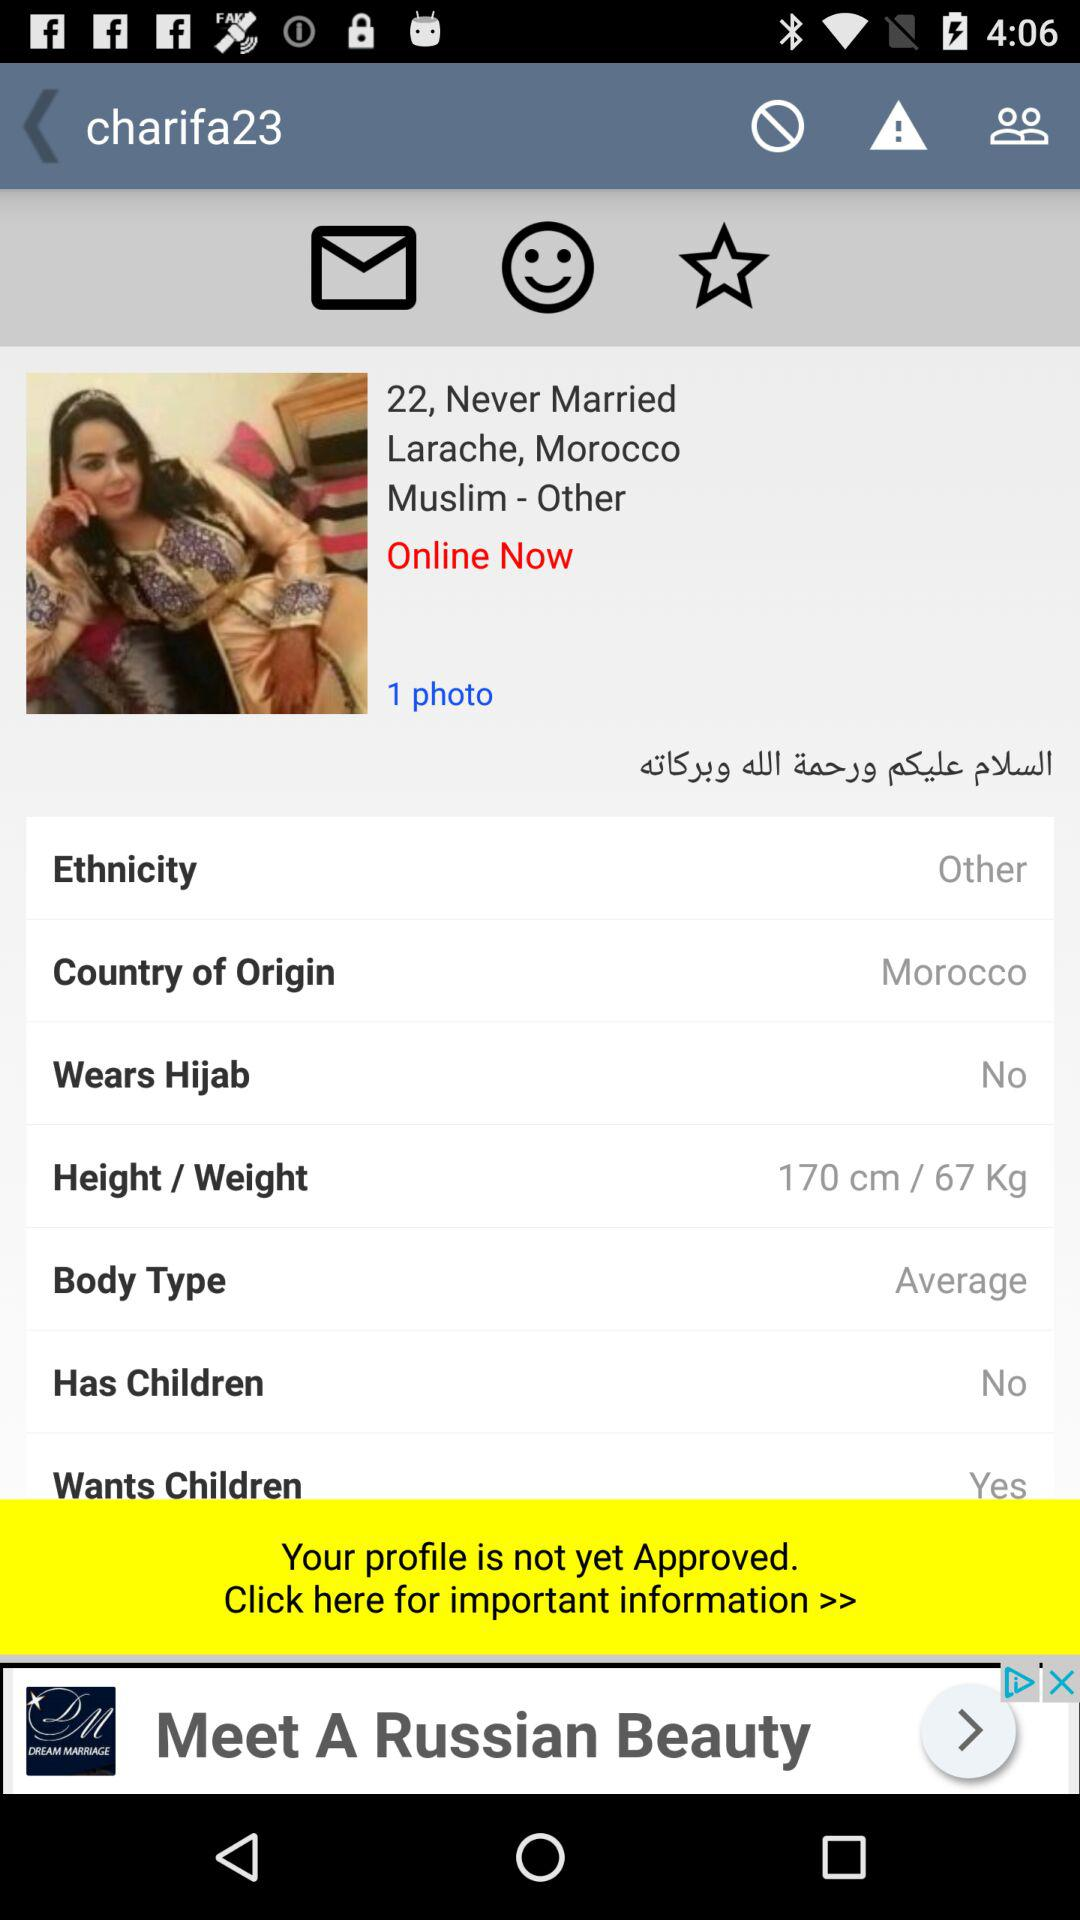Did the user have children? The user has no children. 